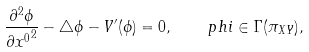Convert formula to latex. <formula><loc_0><loc_0><loc_500><loc_500>\frac { \partial ^ { 2 } \phi } { \partial { x ^ { 0 } } ^ { 2 } } - \triangle \phi - V ^ { \prime } ( \phi ) = 0 , \quad p h i \in \Gamma ( \pi _ { X Y } ) ,</formula> 